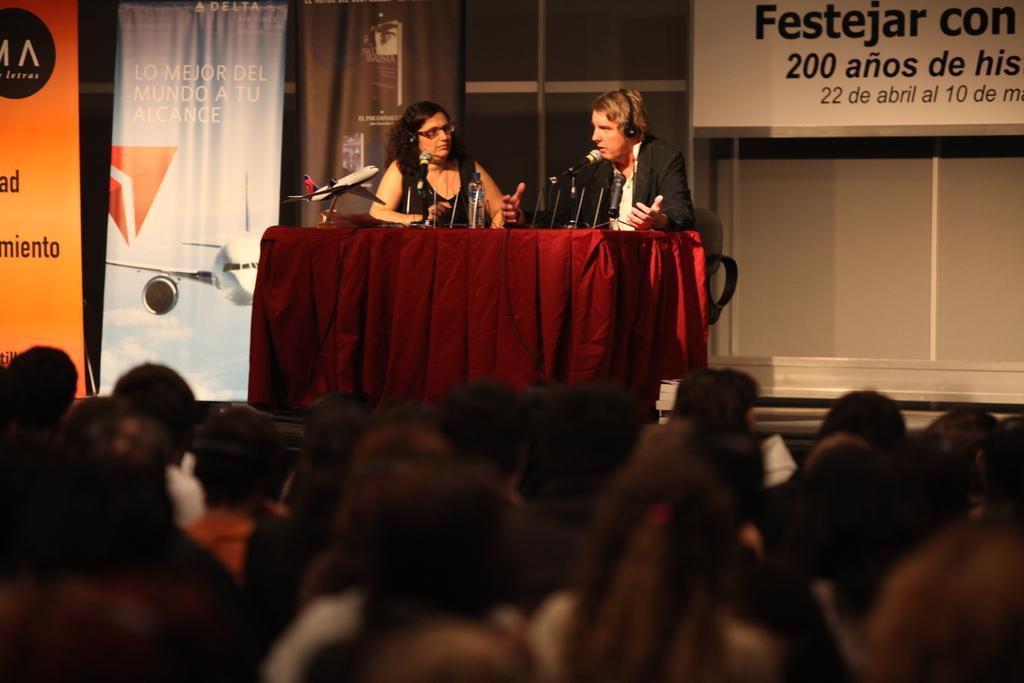In one or two sentences, can you explain what this image depicts? In this picture we can see a group of people sitting. In front of the people, there are two other people sitting on chairs and in front of the two people it looks like a table which is covered by a red cloth. On the table there are microphone, water bottles and a toy airplane. Behind the people there are banners and the wall. 